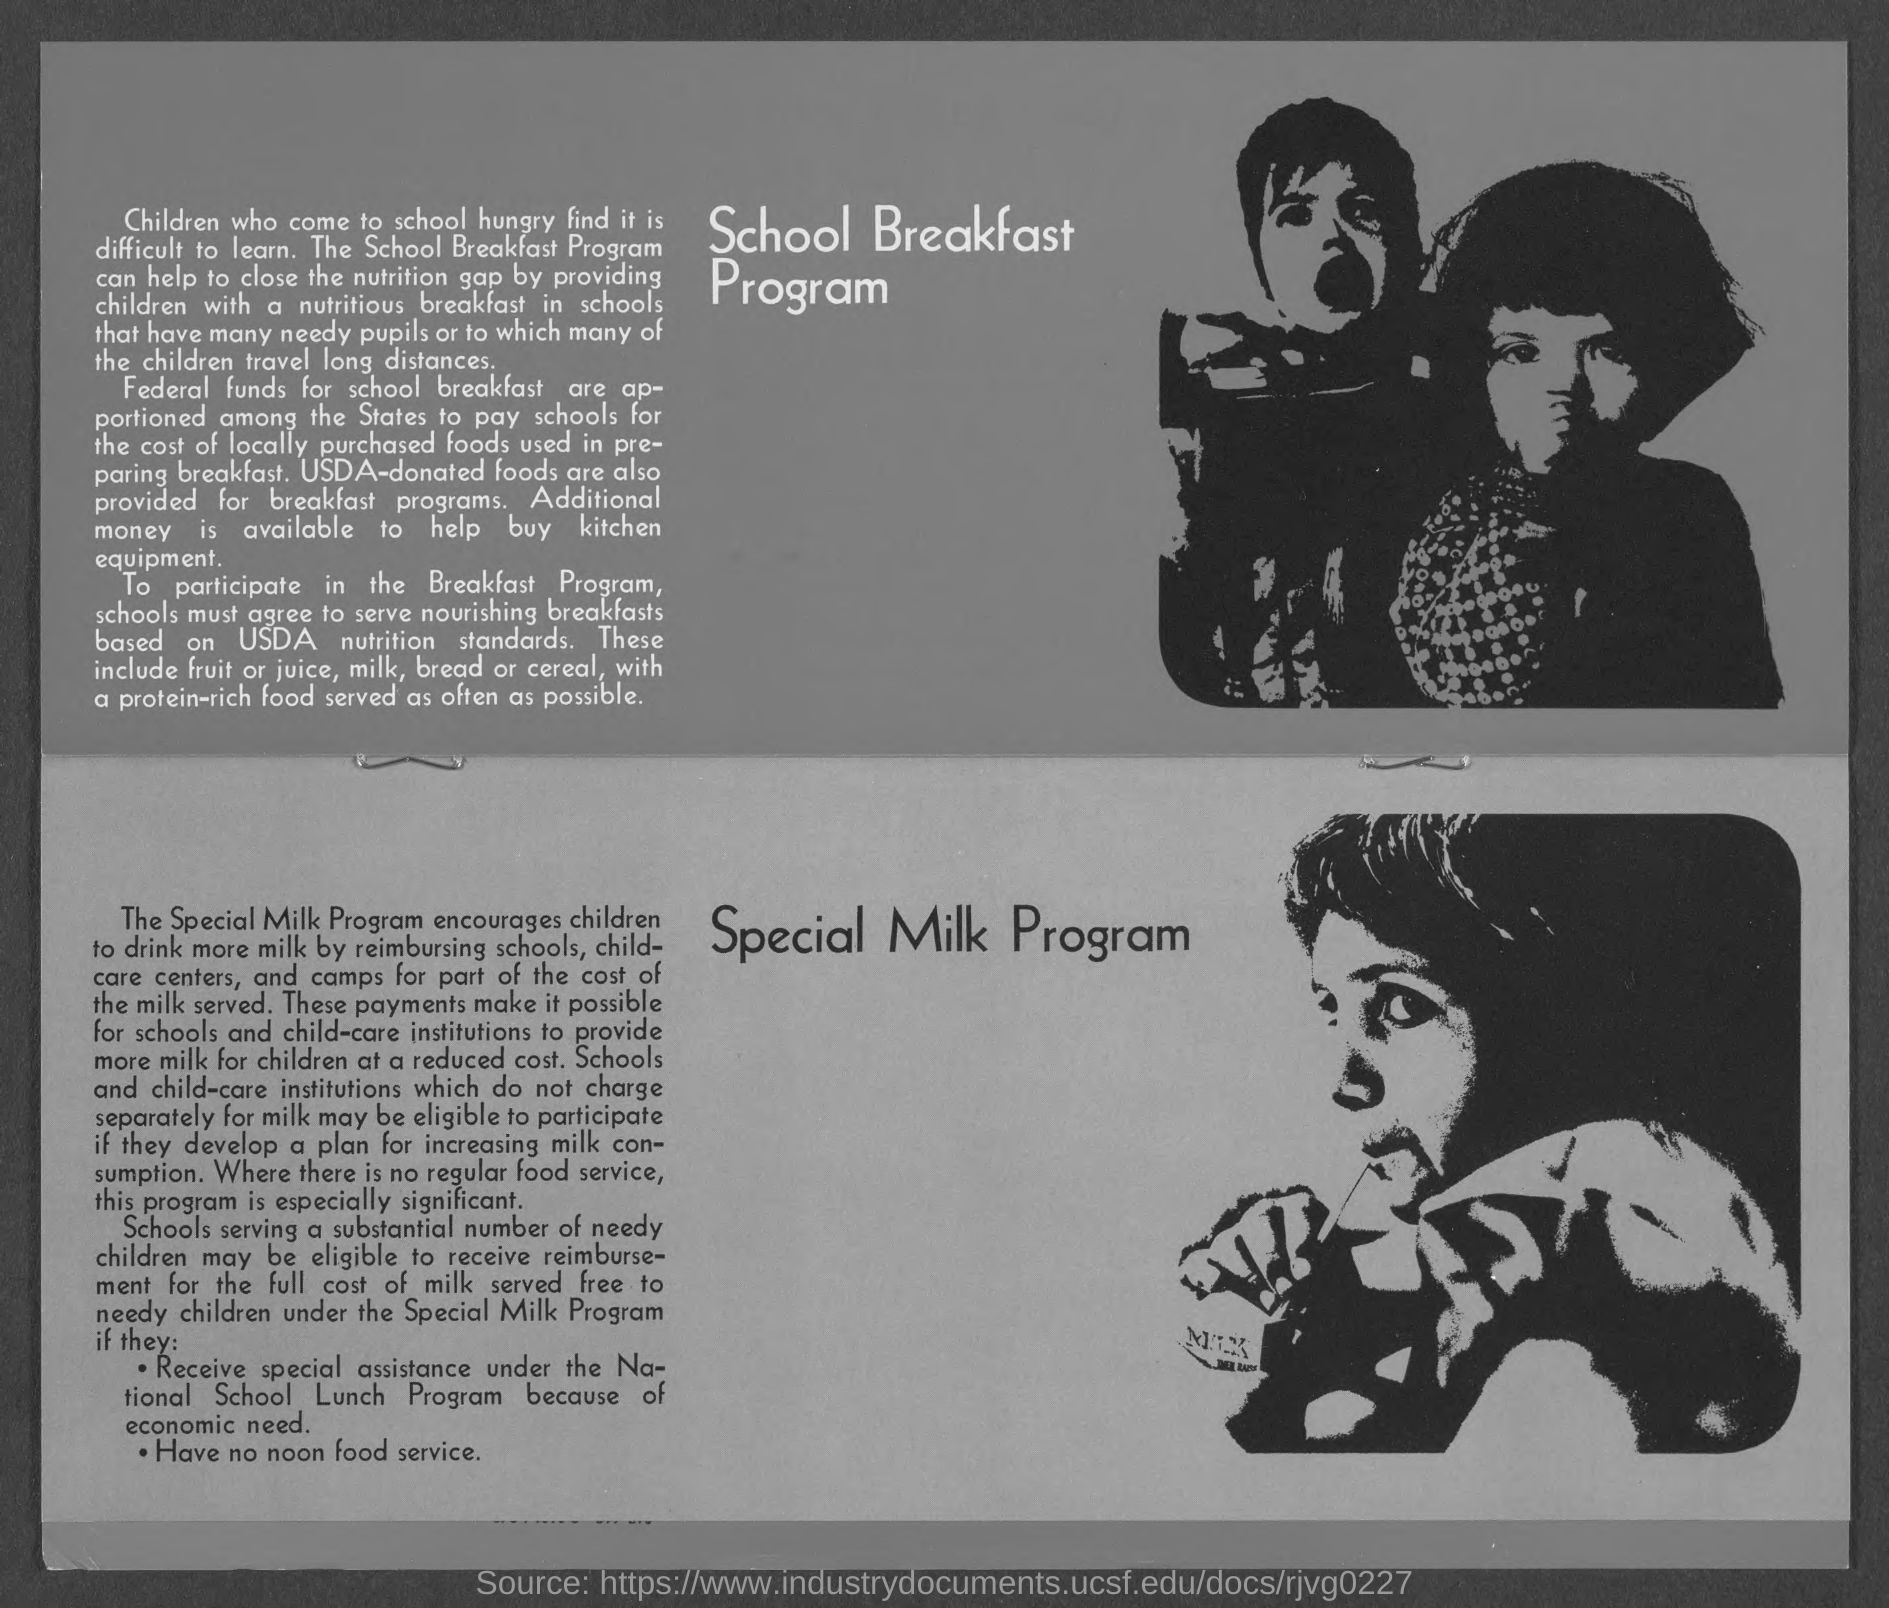What is the heading of the top portion of the document?
Your response must be concise. School Breakfast Program. What is the heading in the bottom portion of the document?
Make the answer very short. Special Milk Program. Schools must agree to serve breakfasts based on what standards?
Your response must be concise. USDA nutrition standards. 